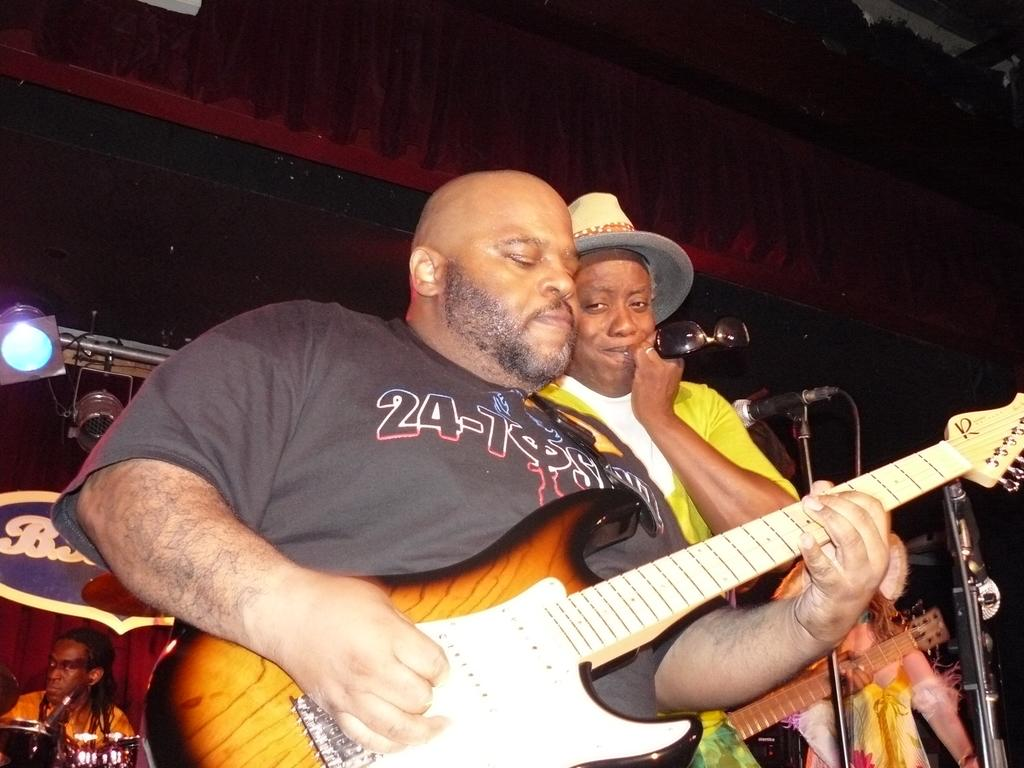What are the people in the image doing? The people in the image are playing musical instruments. Can you describe the person in the middle? The person in the middle is holding goggles. What can be seen in the background of the image? There are banners and a curtain in the background of the image, along with light. What type of poison is being used by the person playing the guitar in the image? There is no poison present in the image; people are playing musical instruments. Is there a fire visible in the image? No, there is no fire visible in the image. 